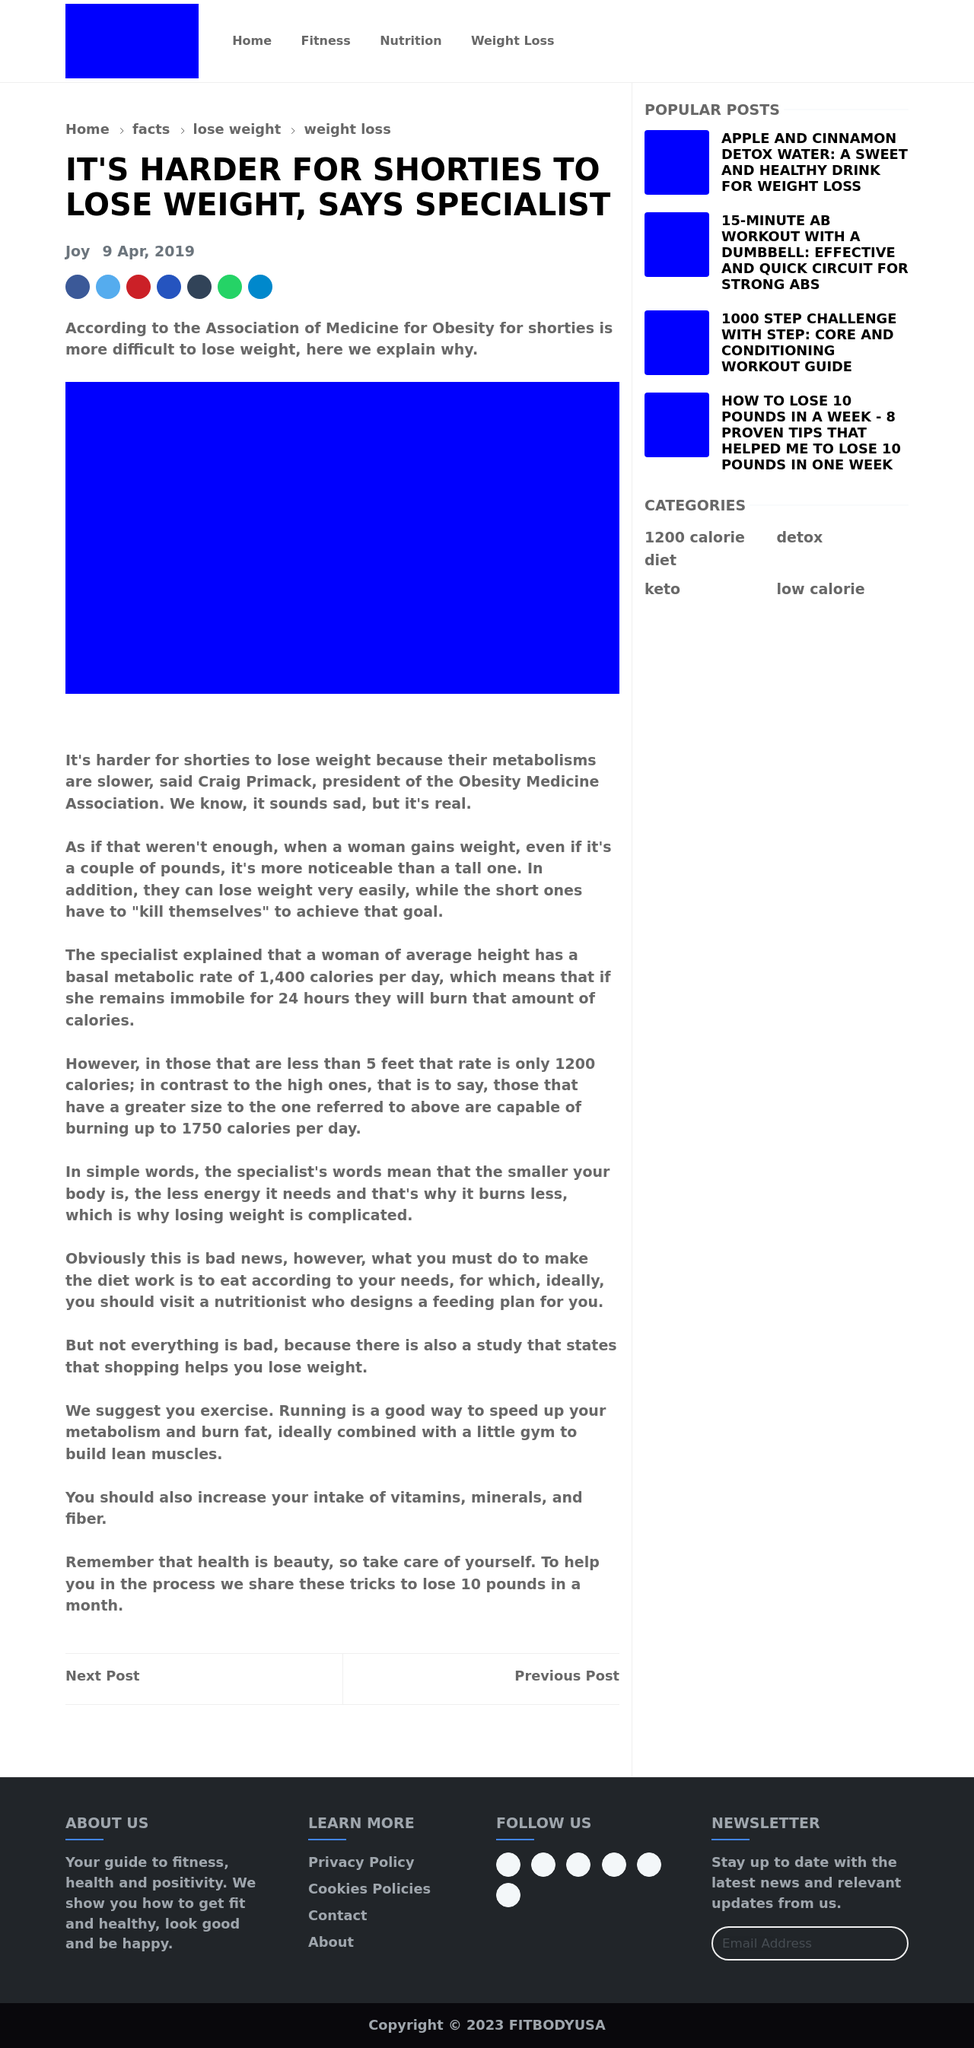Can you describe what specific design elements are present in the website displayed in the image? The website design shown in the image includes a top navigation bar with menu links for different website sections like Home, Fitness, Nutrition, and Weight Loss. It features a main content area that hosts article titles and summaries, potentially clickable to full articles. Sidebar content includes links to popular posts and categories, enhancing navigation. The color scheme involves bright and contrasting colors for different sections to distinguish them visually while maintaining a clean and modern look.  What recommendations would you give to enhance the mobile responsiveness of this website design? To improve the mobile responsiveness of the website, you should utilize CSS media queries to adapt the layout for different screen sizes. This includes stacking elements vertically on smaller screens, adjusting font sizes and button dimensions for easier interaction, and ensuring all images and containers are width-responsive, often using percentages rather than fixed units. Additionally, consider implementing a hamburger-style menu for the mobile version to save space and maintain usability. 